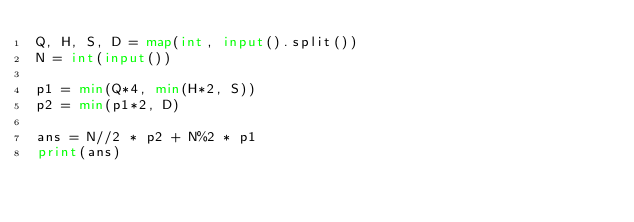<code> <loc_0><loc_0><loc_500><loc_500><_Python_>Q, H, S, D = map(int, input().split())
N = int(input())

p1 = min(Q*4, min(H*2, S))
p2 = min(p1*2, D)

ans = N//2 * p2 + N%2 * p1
print(ans)
</code> 